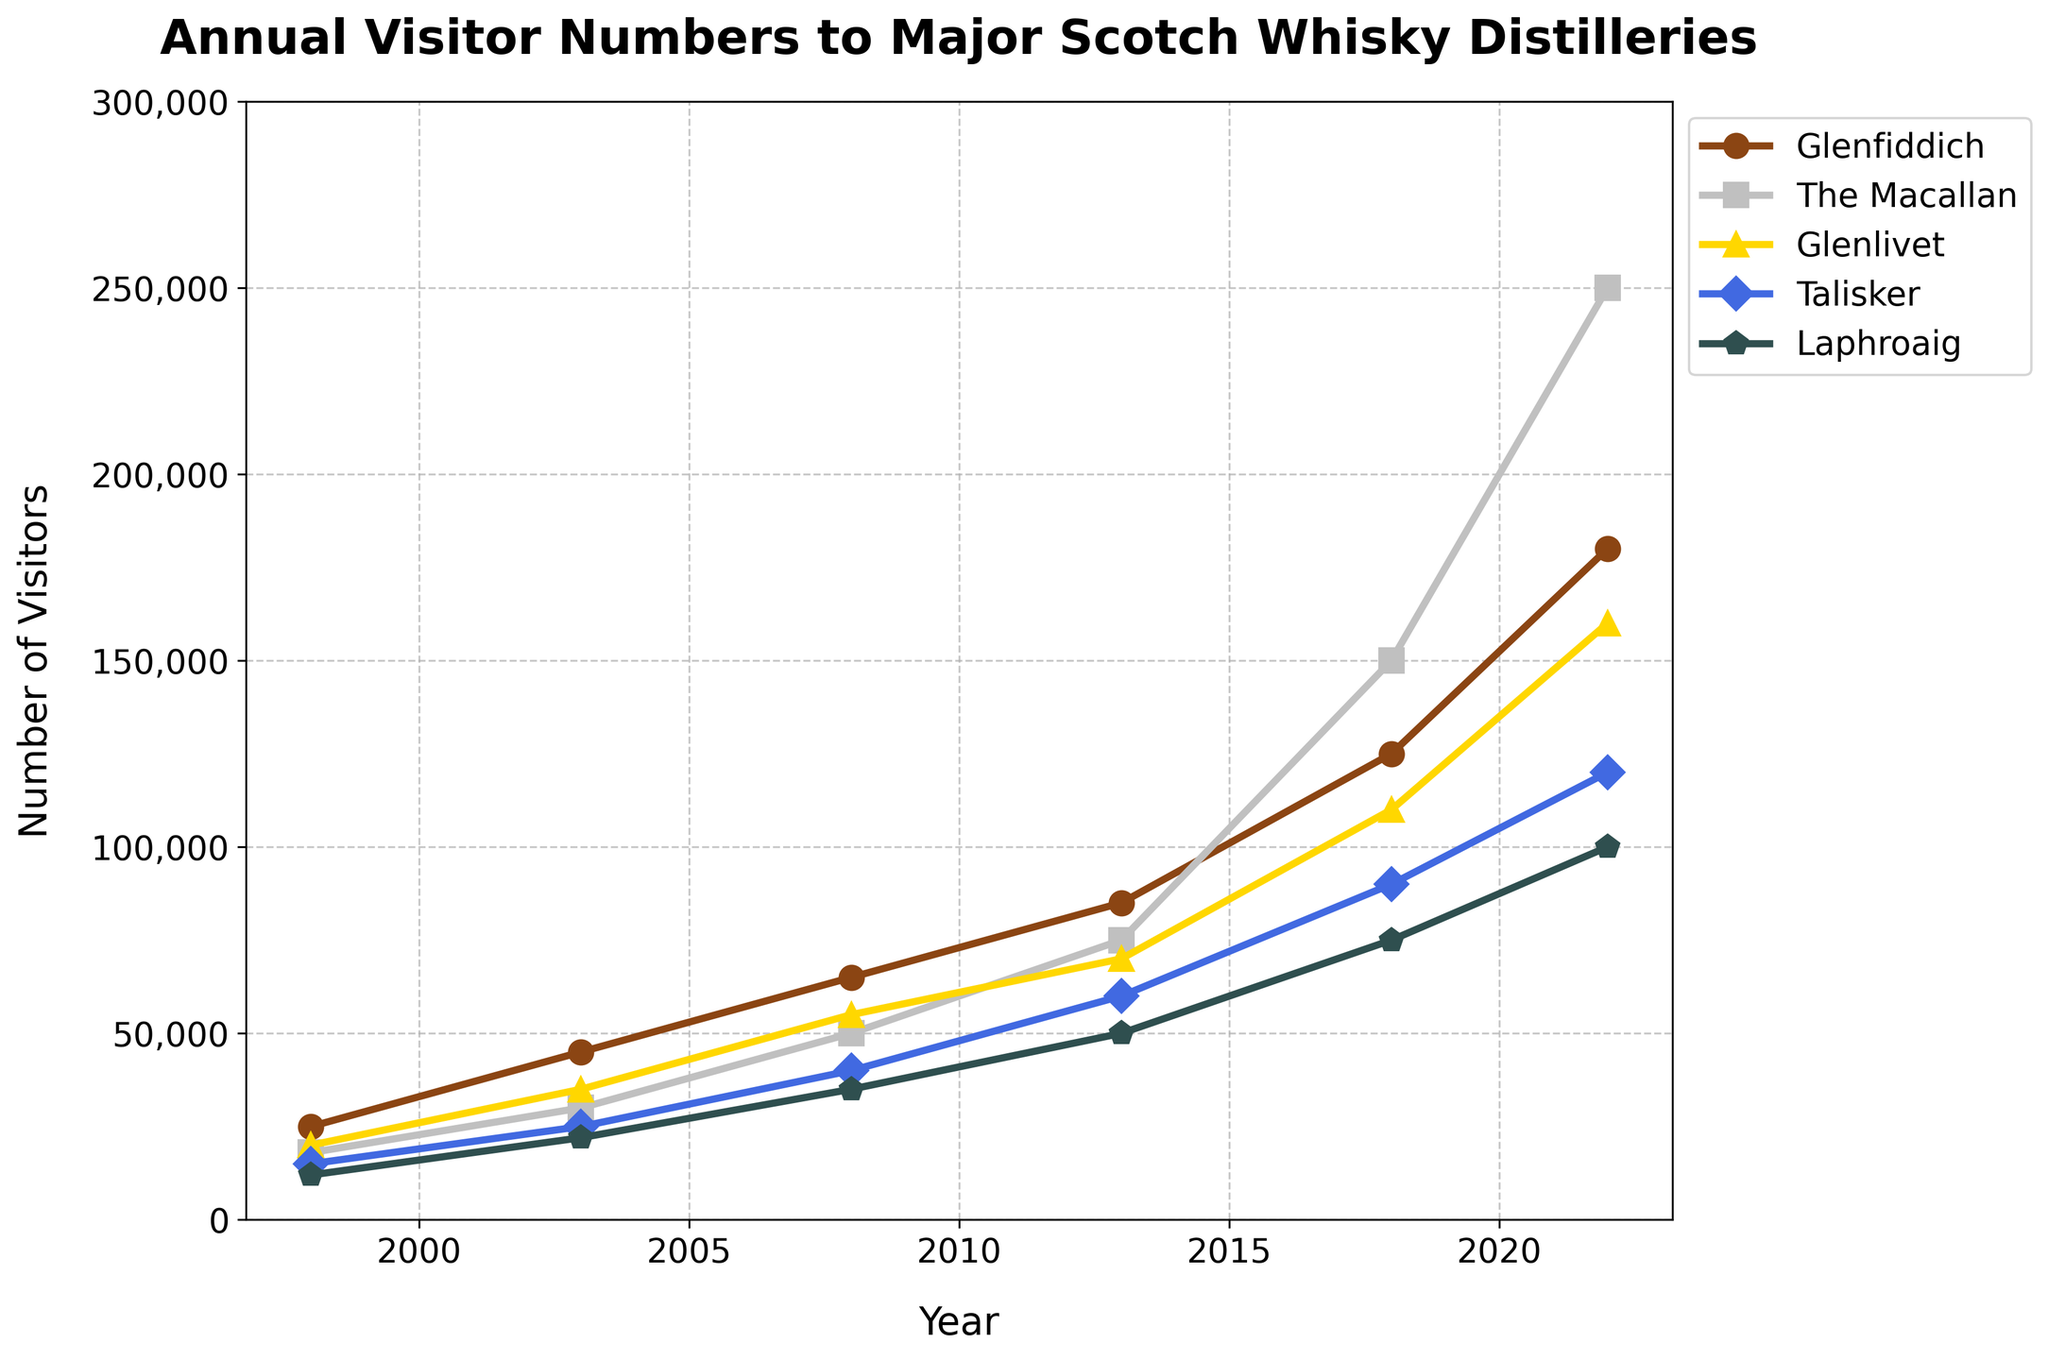What is the overall trend in the number of visitors to Glenfiddich distillery from 1998 to 2022? The number of visitors to Glenfiddich shows a consistent upward trend from 25,000 in 1998 to 180,000 in 2022, reflecting continual growth over the 25 years.
Answer: Continuous growth Which distillery had the highest number of visitors in 2022? In 2022, The Macallan had the highest number of visitors compared to the other distilleries, with a total of 250,000 visitors.
Answer: The Macallan Which distillery experienced the largest increase in visitors between 1998 and 2022? By subtracting the number of visitors in 1998 from the number of visitors in 2022 for each distillery, The Macallan shows the largest increase, rising from 18,000 in 1998 to 250,000 in 2022.
Answer: The Macallan By how much did the number of visitors to Laphroaig change from 1998 to 2022? The number of visitors to Laphroaig in 1998 was 12,000 and increased to 100,000 in 2022. This results in a change of 88,000.
Answer: 88,000 How does the increase in visitors to Talisker from 2008 to 2018 compare to the increase from 2018 to 2022? From 2008 to 2018, Talisker saw an increase from 40,000 to 90,000 visitors (50,000 increase). From 2018 to 2022, the number increased from 90,000 to 120,000 (30,000 increase). The first period (2008-2018) experienced a larger increase.
Answer: 2008-2018 had a larger increase Among the five distilleries, which one had the smallest number of visitors in 1998, and how many visitors was that? In 1998, Laphroaig had the smallest number of visitors, totaling 12,000.
Answer: Laphroaig, 12,000 Which distillery had the sharpest increase in visitors between any two consecutive data points, and what is the value of that increase? The Macallan had the sharpest increase between 2018 (150,000) and 2022 (250,000), resulting in an increase of 100,000.
Answer: The Macallan, 100,000 What is the average number of visitors to Glenlivet in the years provided? The number of visitors to Glenlivet over the provided years are 20,000, 35,000, 55,000, 70,000, 110,000, and 160,000. The sum is 450,000. Dividing by the 6 years gives an average of 75,000.
Answer: 75,000 Between which years did Glenfiddich experience the largest proportional growth in visitors? The largest proportional growth can be found between 2018 and 2022. Visitors increased from 125,000 to 180,000. The proportional growth is (180,000 - 125,000)/125,000 = 0.44 or 44%.
Answer: 2018-2022 What noticeable trend is present among all distilleries over the 25 years? All distilleries show a consistent increase in visitor numbers from 1998 to 2022, indicating a general rise in popularity or interest in Scotch whisky distilleries over the years.
Answer: Consistent increase 